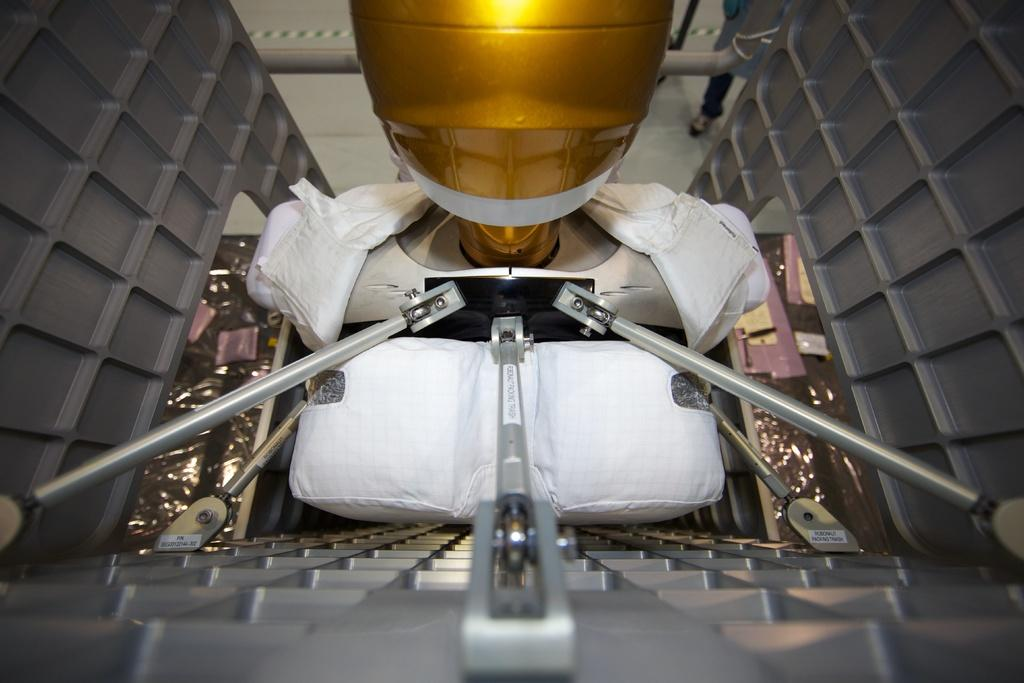What type of object is the main subject in the picture? There is a machine equipment in the picture. Can you describe any specific features of the machine equipment? Unfortunately, the provided facts do not give any specific details about the machine equipment. What color is the object at the top of the picture? The object at the top of the picture has a gold color. What other color is present in the picture? There is a white color cloth in the picture. How many frogs can be seen jumping on the machine equipment in the image? There are no frogs present in the image; it features a machine equipment, a gold color object at the top, and a white color cloth. 